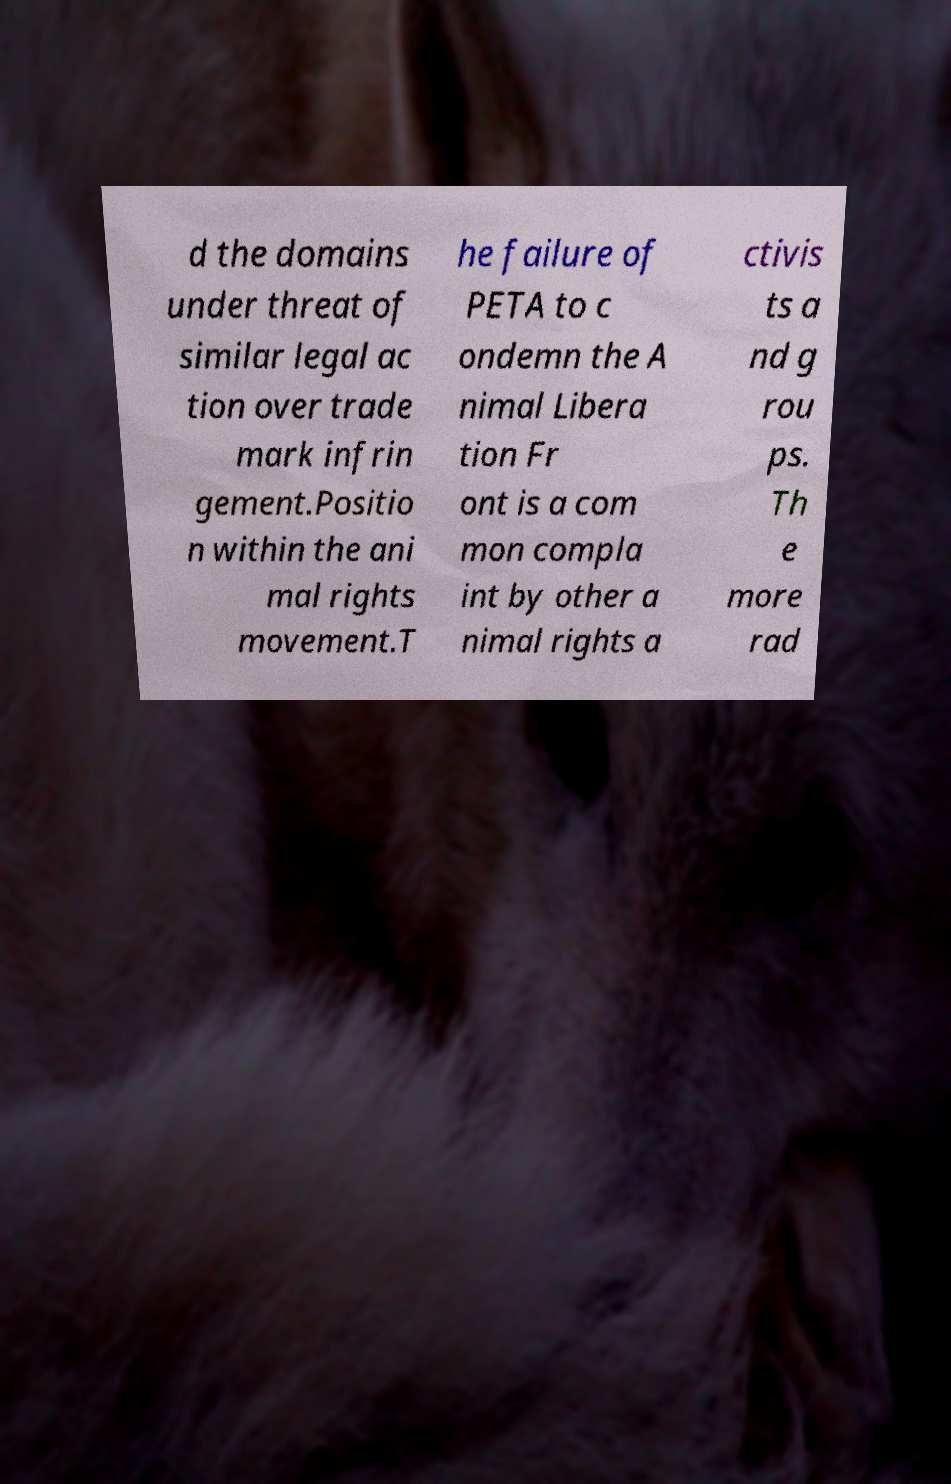Could you assist in decoding the text presented in this image and type it out clearly? d the domains under threat of similar legal ac tion over trade mark infrin gement.Positio n within the ani mal rights movement.T he failure of PETA to c ondemn the A nimal Libera tion Fr ont is a com mon compla int by other a nimal rights a ctivis ts a nd g rou ps. Th e more rad 